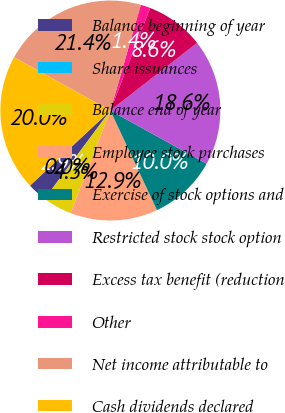<chart> <loc_0><loc_0><loc_500><loc_500><pie_chart><fcel>Balance beginning of year<fcel>Share issuances<fcel>Balance end of year<fcel>Employee stock purchases<fcel>Exercise of stock options and<fcel>Restricted stock stock option<fcel>Excess tax benefit (reduction<fcel>Other<fcel>Net income attributable to<fcel>Cash dividends declared<nl><fcel>2.86%<fcel>0.0%<fcel>4.29%<fcel>12.86%<fcel>10.0%<fcel>18.57%<fcel>8.57%<fcel>1.43%<fcel>21.43%<fcel>20.0%<nl></chart> 